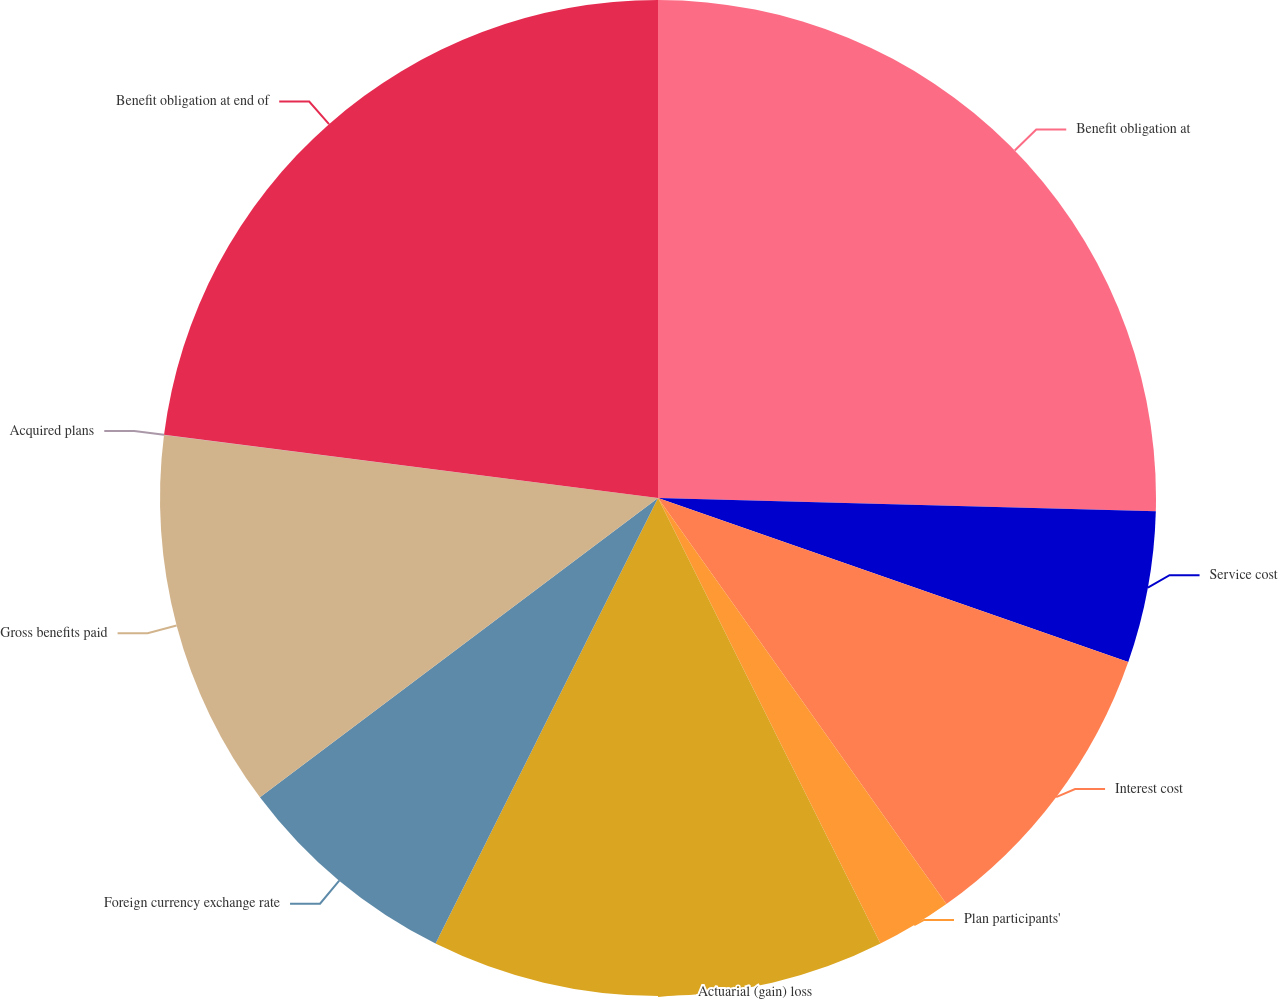<chart> <loc_0><loc_0><loc_500><loc_500><pie_chart><fcel>Benefit obligation at<fcel>Service cost<fcel>Interest cost<fcel>Plan participants'<fcel>Actuarial (gain) loss<fcel>Foreign currency exchange rate<fcel>Gross benefits paid<fcel>Acquired plans<fcel>Benefit obligation at end of<nl><fcel>25.42%<fcel>4.92%<fcel>9.83%<fcel>2.46%<fcel>14.74%<fcel>7.37%<fcel>12.28%<fcel>0.01%<fcel>22.97%<nl></chart> 